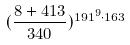<formula> <loc_0><loc_0><loc_500><loc_500>( \frac { 8 + 4 1 3 } { 3 4 0 } ) ^ { 1 9 1 ^ { 9 } \cdot 1 6 3 }</formula> 